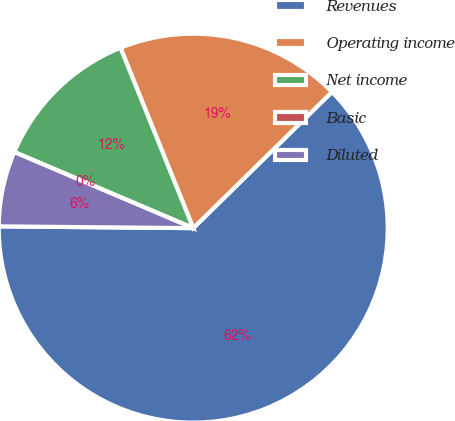Convert chart to OTSL. <chart><loc_0><loc_0><loc_500><loc_500><pie_chart><fcel>Revenues<fcel>Operating income<fcel>Net income<fcel>Basic<fcel>Diluted<nl><fcel>62.5%<fcel>18.75%<fcel>12.5%<fcel>0.0%<fcel>6.25%<nl></chart> 